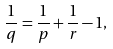Convert formula to latex. <formula><loc_0><loc_0><loc_500><loc_500>\frac { 1 } { q } = \frac { 1 } { p } + \frac { 1 } { r } - 1 ,</formula> 